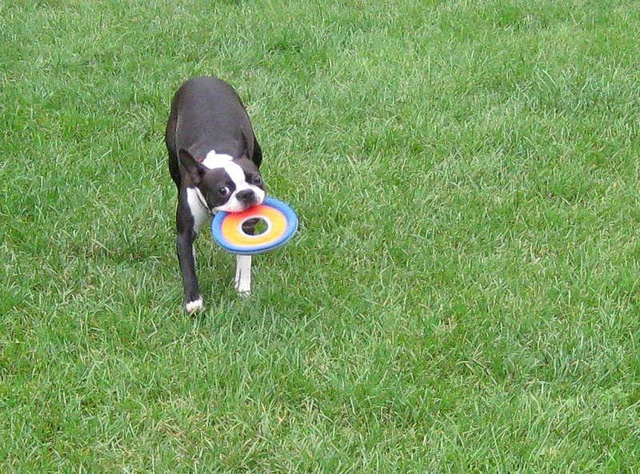Describe the objects in this image and their specific colors. I can see dog in lightgreen, gray, black, white, and darkgray tones and frisbee in lightgreen, khaki, lightgray, and lightblue tones in this image. 